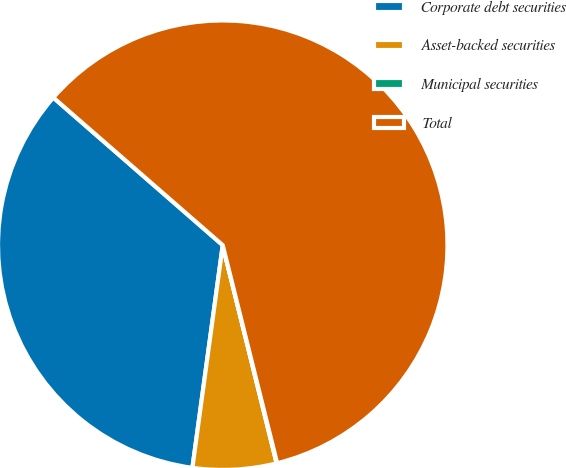<chart> <loc_0><loc_0><loc_500><loc_500><pie_chart><fcel>Corporate debt securities<fcel>Asset-backed securities<fcel>Municipal securities<fcel>Total<nl><fcel>34.25%<fcel>6.01%<fcel>0.04%<fcel>59.7%<nl></chart> 